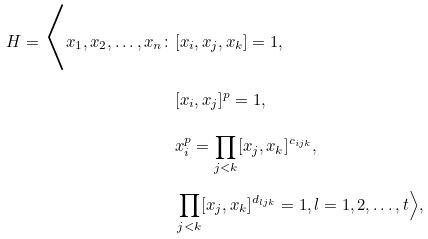<formula> <loc_0><loc_0><loc_500><loc_500>H = \Big { \langle } x _ { 1 } , x _ { 2 } , \dots , x _ { n } \colon & [ x _ { i } , x _ { j } , x _ { k } ] = 1 , \\ & [ x _ { i } , x _ { j } ] ^ { p } = 1 , \\ & x _ { i } ^ { p } = \prod _ { j < k } [ x _ { j } , x _ { k } ] ^ { c _ { i j k } } , \\ & \prod _ { j < k } [ x _ { j } , x _ { k } ] ^ { d _ { l j k } } = 1 , l = 1 , 2 , \dots , t \Big { \rangle } ,</formula> 